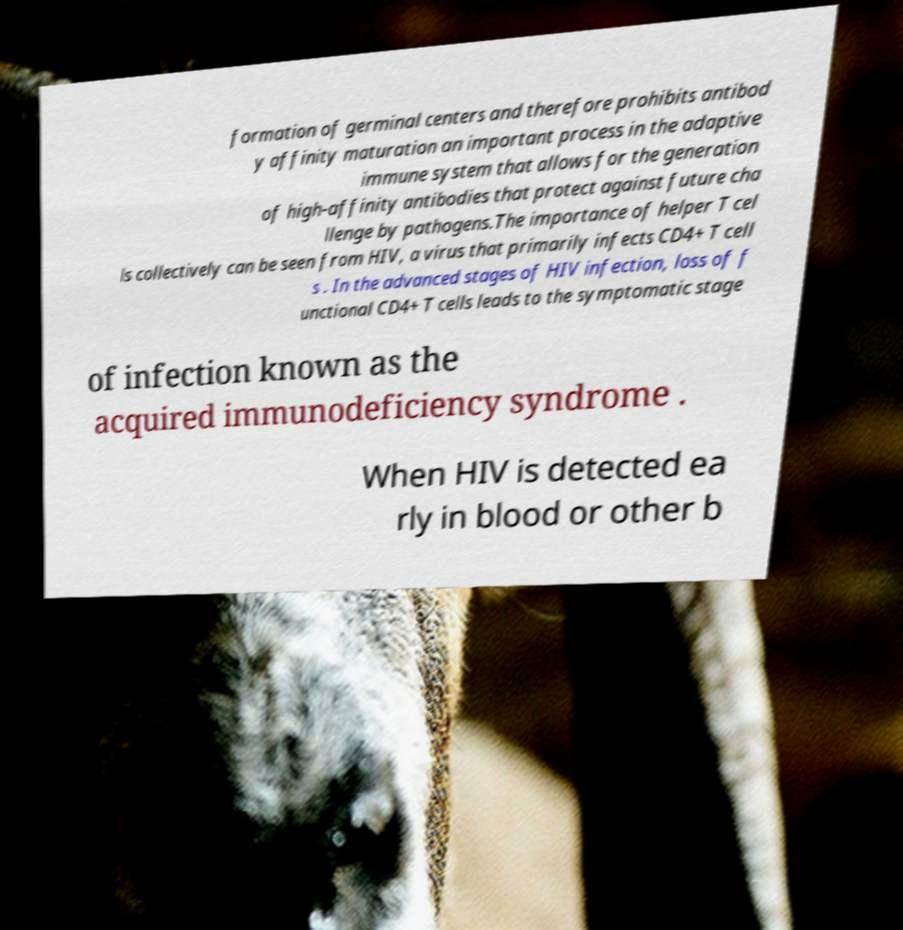I need the written content from this picture converted into text. Can you do that? formation of germinal centers and therefore prohibits antibod y affinity maturation an important process in the adaptive immune system that allows for the generation of high-affinity antibodies that protect against future cha llenge by pathogens.The importance of helper T cel ls collectively can be seen from HIV, a virus that primarily infects CD4+ T cell s . In the advanced stages of HIV infection, loss of f unctional CD4+ T cells leads to the symptomatic stage of infection known as the acquired immunodeficiency syndrome . When HIV is detected ea rly in blood or other b 